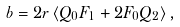Convert formula to latex. <formula><loc_0><loc_0><loc_500><loc_500>b = 2 r \left \langle Q _ { 0 } F _ { 1 } + 2 F _ { 0 } Q _ { 2 } \right \rangle ,</formula> 